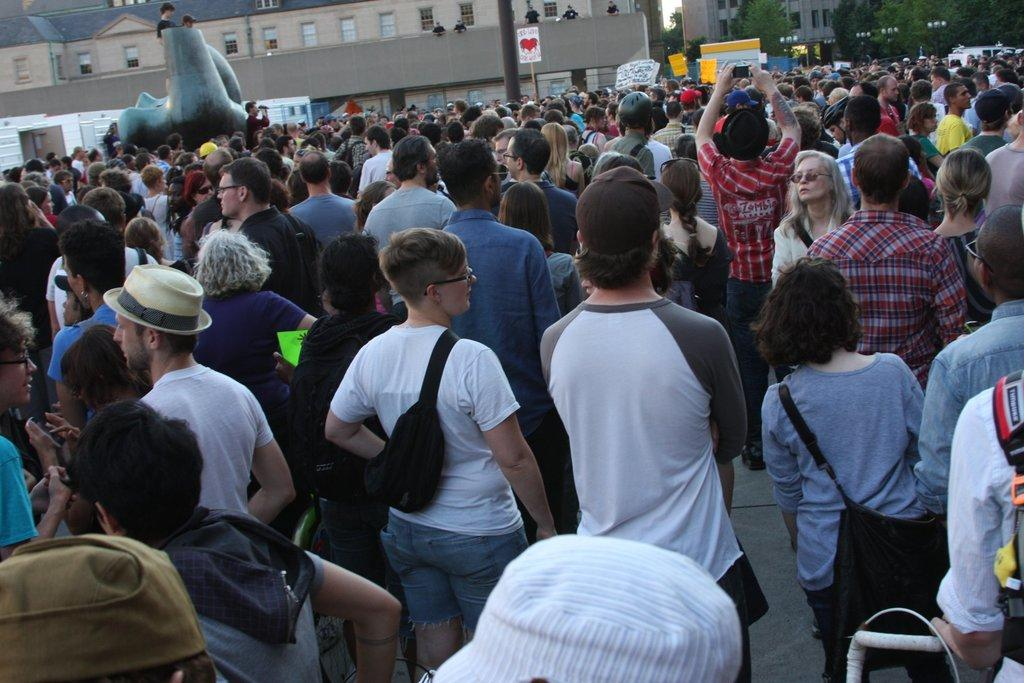What is the main focus of the image? The main focus of the image is the many people in the center. What else can be seen in the image besides the people? There are buildings and trees in the image. Where are the trees located in the image? The trees are at the top side of the image. What else is present in the center of the image? There are posters in the center of the image. How many passengers are waiting for the meeting to start in the image? There is no reference to passengers or a meeting in the image; it features people, buildings, trees, and posters. Can you spot the rat hiding behind the poster in the image? There is no rat present in the image. 